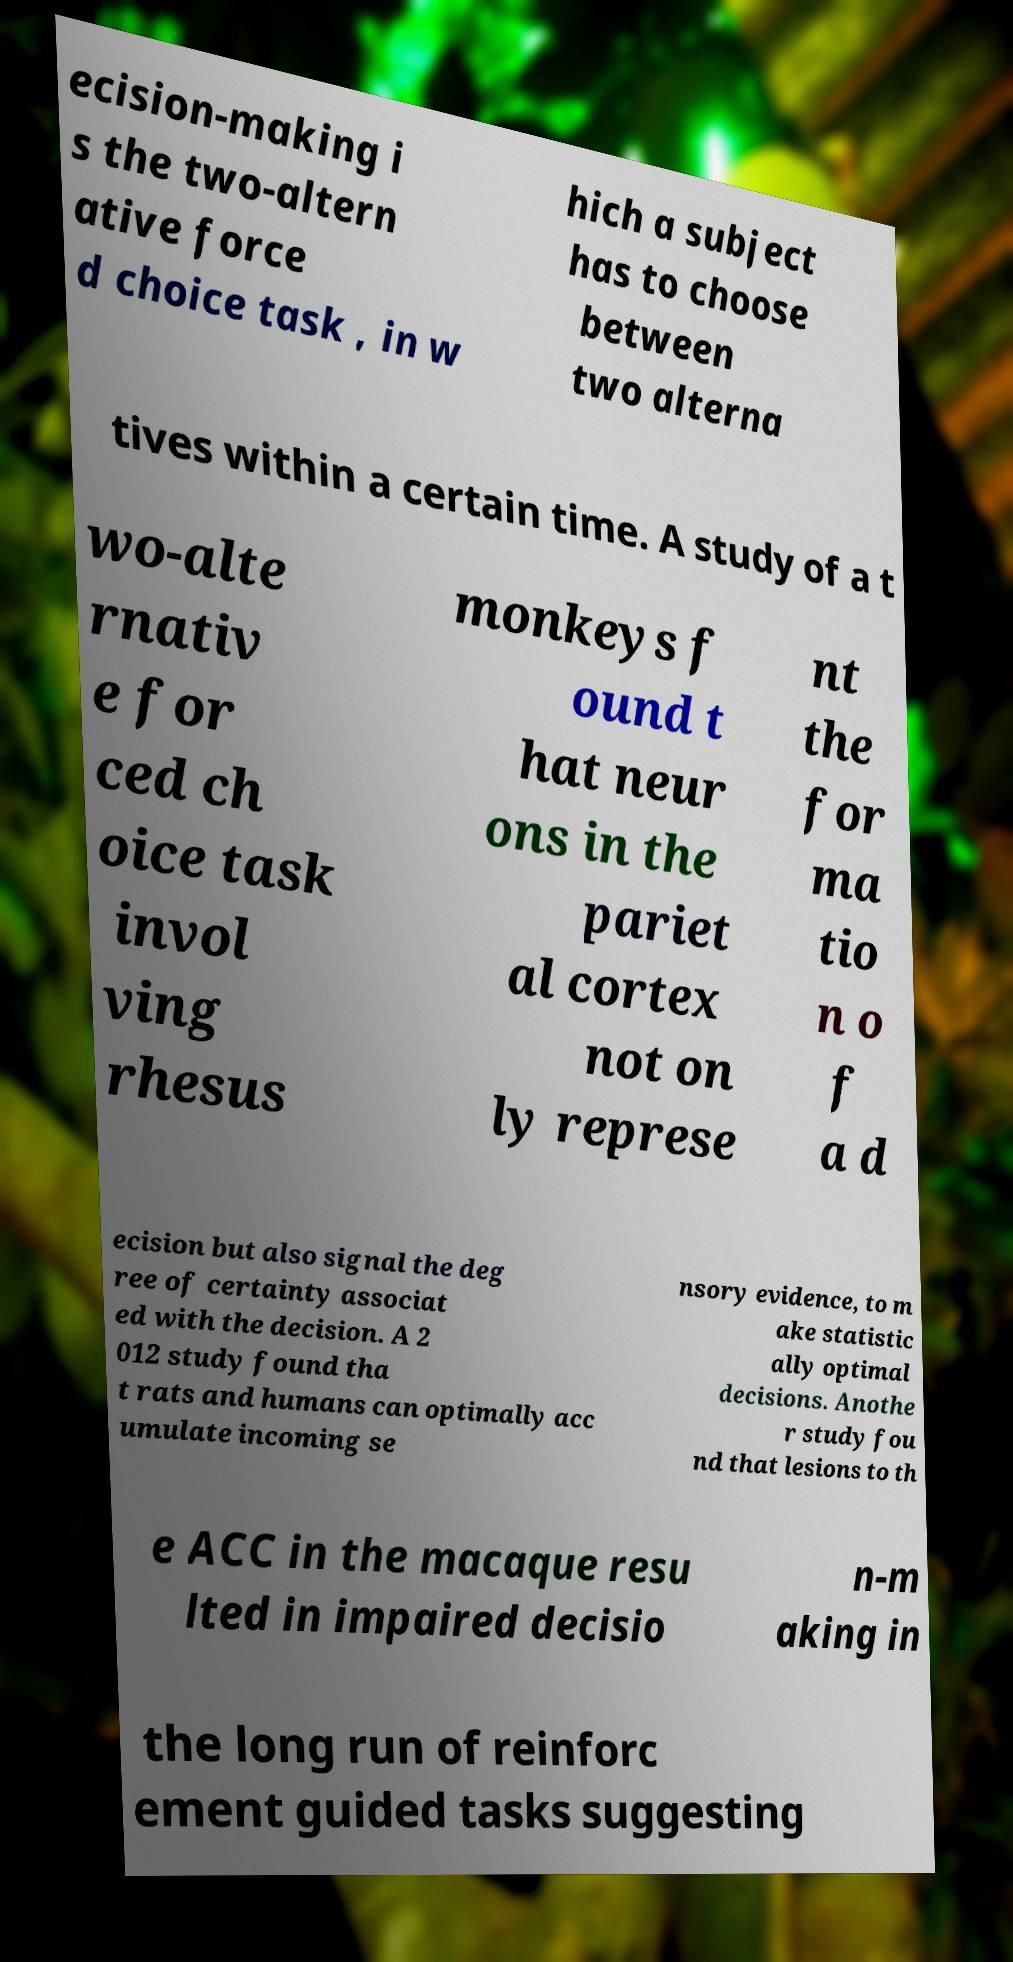There's text embedded in this image that I need extracted. Can you transcribe it verbatim? ecision-making i s the two-altern ative force d choice task , in w hich a subject has to choose between two alterna tives within a certain time. A study of a t wo-alte rnativ e for ced ch oice task invol ving rhesus monkeys f ound t hat neur ons in the pariet al cortex not on ly represe nt the for ma tio n o f a d ecision but also signal the deg ree of certainty associat ed with the decision. A 2 012 study found tha t rats and humans can optimally acc umulate incoming se nsory evidence, to m ake statistic ally optimal decisions. Anothe r study fou nd that lesions to th e ACC in the macaque resu lted in impaired decisio n-m aking in the long run of reinforc ement guided tasks suggesting 